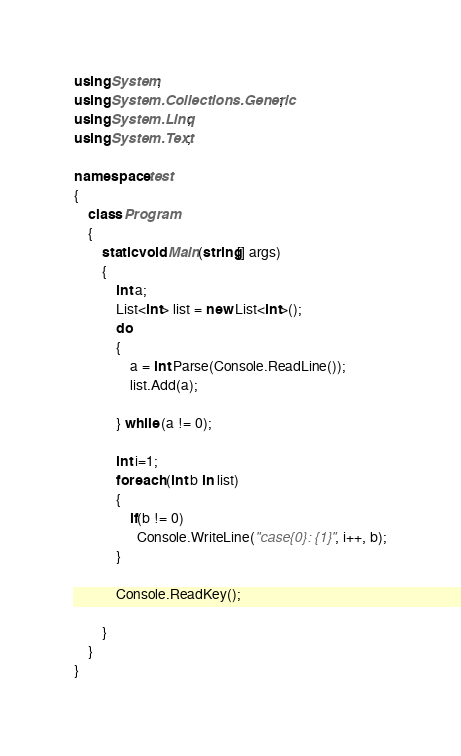Convert code to text. <code><loc_0><loc_0><loc_500><loc_500><_C#_>using System;
using System.Collections.Generic;
using System.Linq;
using System.Text;

namespace test
{
    class Program
    {
        static void Main(string[] args)
        {
            int a;
            List<int> list = new List<int>();
            do
            {
                a = int.Parse(Console.ReadLine());
                list.Add(a);

            } while (a != 0);

            int i=1;
            foreach (int b in list)
            {
                if(b != 0)
                  Console.WriteLine("case{0}: {1}", i++, b);
            }

            Console.ReadKey();
           
        }
    }
}</code> 